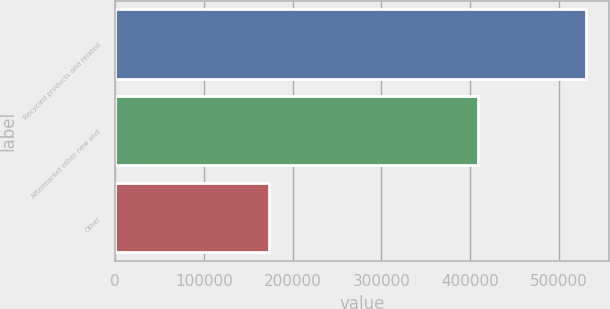Convert chart. <chart><loc_0><loc_0><loc_500><loc_500><bar_chart><fcel>Recycled products and related<fcel>Aftermarket other new and<fcel>Other<nl><fcel>530152<fcel>409304<fcel>172895<nl></chart> 